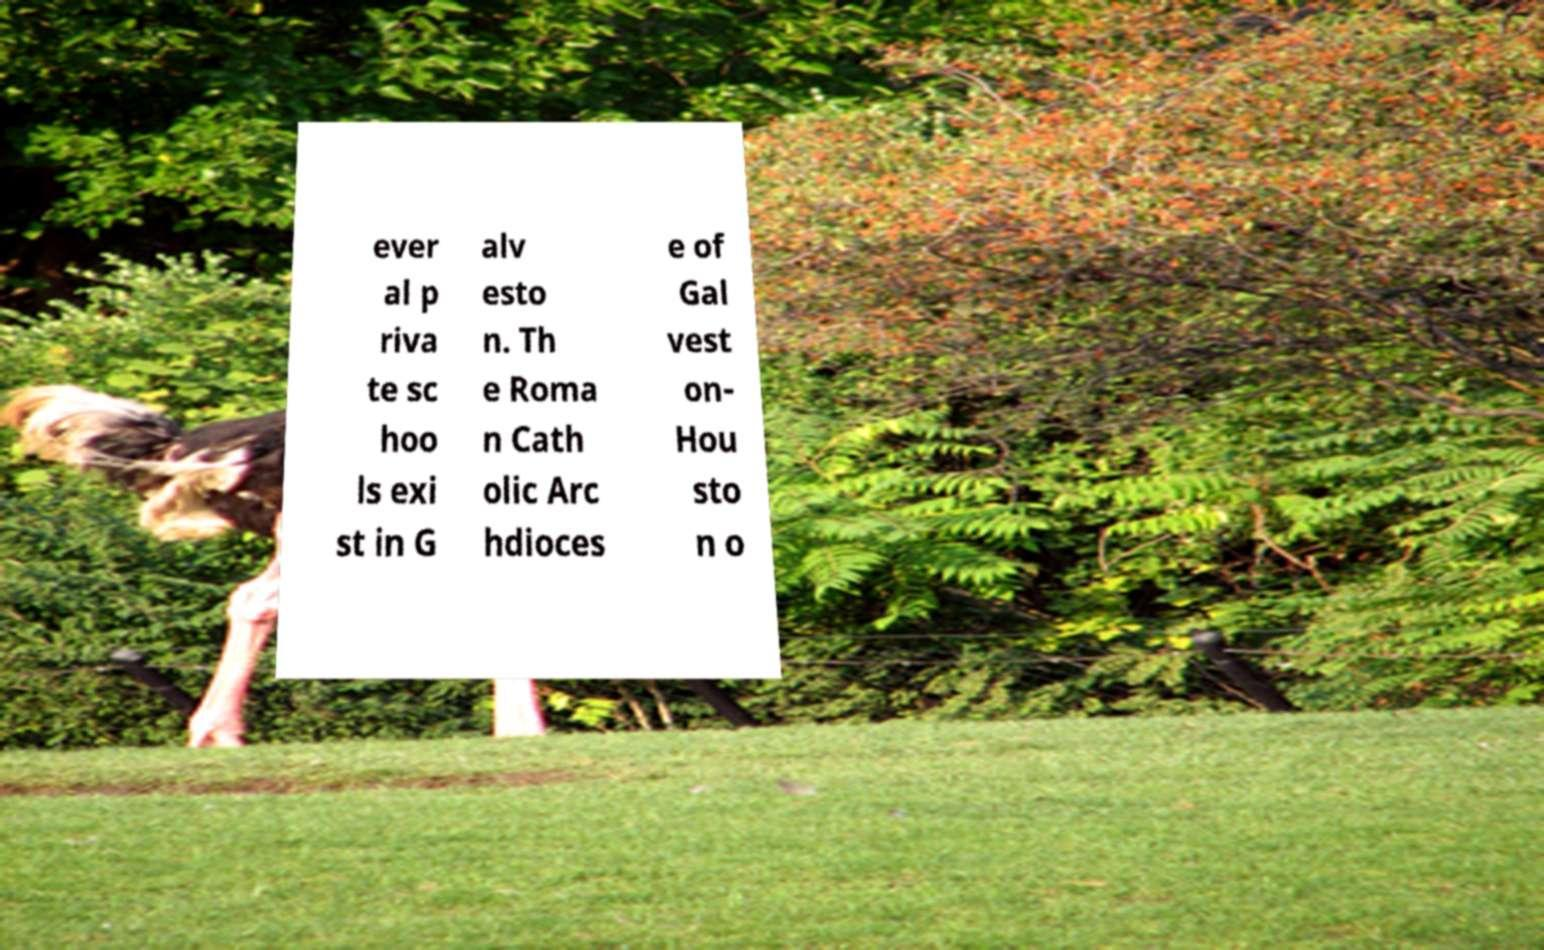For documentation purposes, I need the text within this image transcribed. Could you provide that? ever al p riva te sc hoo ls exi st in G alv esto n. Th e Roma n Cath olic Arc hdioces e of Gal vest on- Hou sto n o 